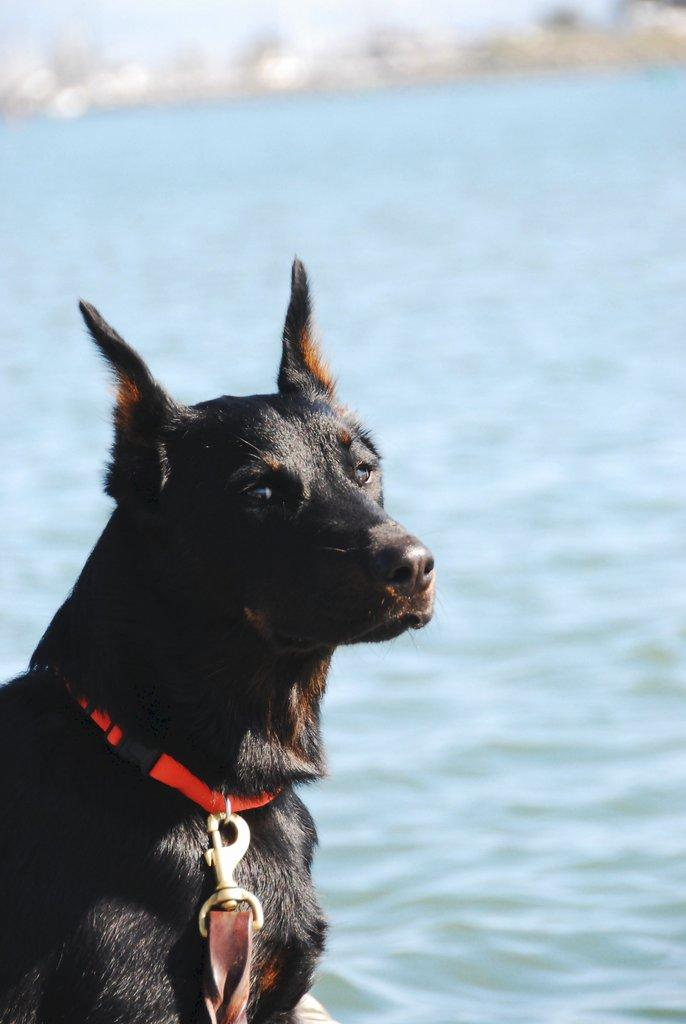What type of animal is in the image? There is a black color dog in the image. What object can be seen in the image? There is a belt in the image. What can be seen in the background of the image? There is water visible in the background of the image. How many bees are sitting on the dog in the image? There are no bees present in the image. What type of vessel is floating on the water in the background? There is no vessel visible in the image; only water can be seen in the background. 